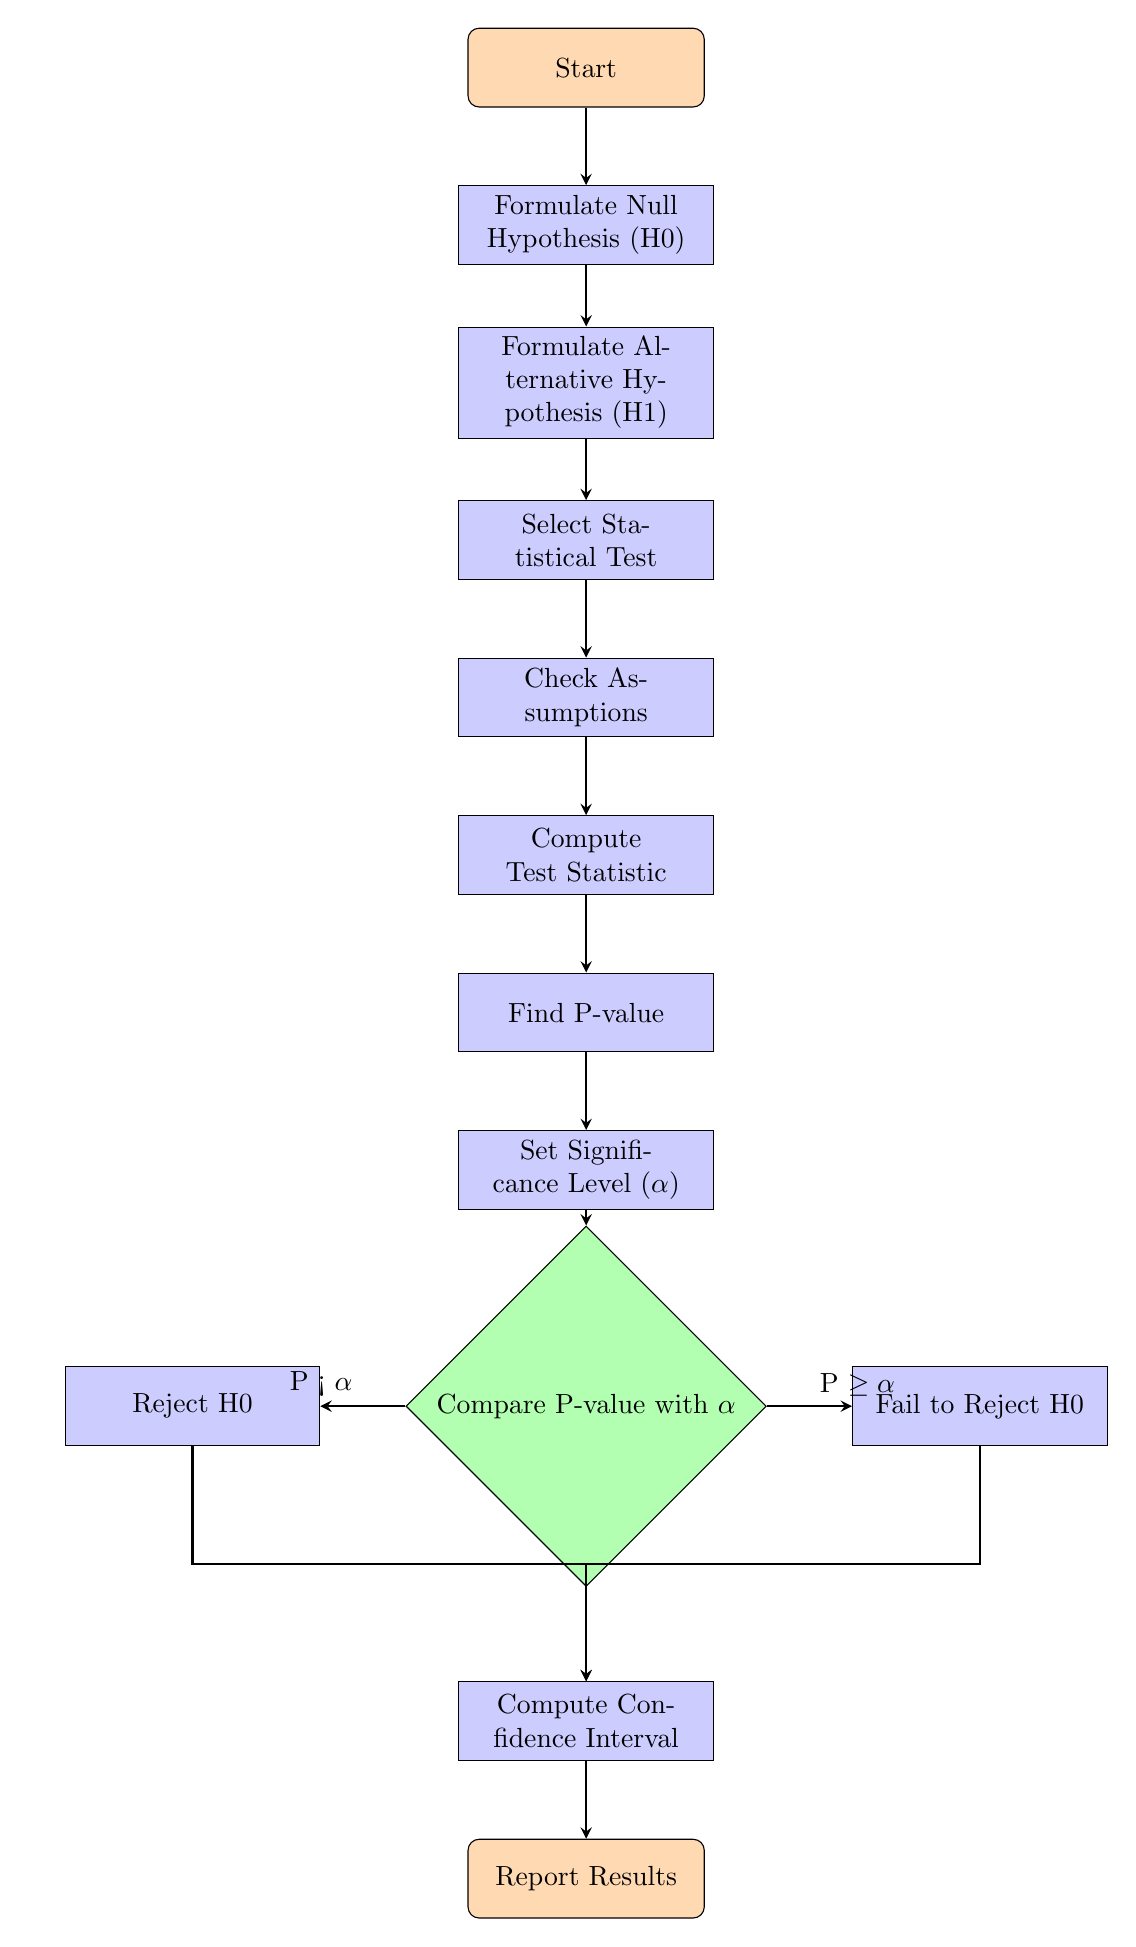What is the first step in the workflow? The first step in the workflow is to "Formulate Null Hypothesis (H0)," as indicated at the top of the diagram, directly below the "Start" node.
Answer: Formulate Null Hypothesis (H0) How many decision nodes are in the diagram? There is one decision node in the diagram, which is labeled "Compare P-value with α." This is the only diamond-shaped node present in the workflow.
Answer: One What happens if the P-value is greater than or equal to α? If the P-value is greater than or equal to α, the workflow indicates "Fail to Reject H0," which is the next step for that branch of the process.
Answer: Fail to Reject H0 What steps follow after computing the Test Statistic? After computing the Test Statistic, the next steps in the workflow are to "Find P-value," then "Set Significance Level (α)." These steps follow sequentially in the diagram.
Answer: Find P-value, Set Significance Level (α) What is the final step in the workflow? The final step in the workflow is "Report Results." This step comes after either rejecting the null hypothesis or failing to reject it and computing the confidence interval.
Answer: Report Results If you reject H0, what is the subsequent action to take? When rejecting H0, the next action to take is to "Compute Confidence Interval," which is the continuation from the "Reject H0" process step in the diagram.
Answer: Compute Confidence Interval How many process nodes are there in total? The diagram includes six process nodes: "Formulate Null Hypothesis (H0)," "Formulate Alternative Hypothesis (H1)," "Select Statistical Test," "Check Assumptions," "Compute Test Statistic," and "Find P-value."
Answer: Six What do you need to set before comparing the P-value with α? Before comparing the P-value with α, you need to "Set Significance Level (α)," which is a prerequisite step in the workflow leading to the comparison.
Answer: Set Significance Level (α) 